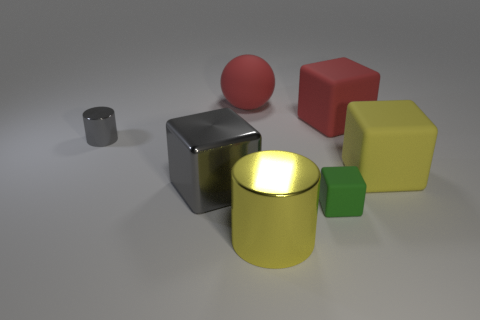Subtract all purple cubes. Subtract all yellow spheres. How many cubes are left? 4 Add 1 green rubber cubes. How many objects exist? 8 Subtract all cubes. How many objects are left? 3 Add 4 large red objects. How many large red objects exist? 6 Subtract 0 cyan cylinders. How many objects are left? 7 Subtract all tiny metal objects. Subtract all purple metallic cubes. How many objects are left? 6 Add 7 large metal cubes. How many large metal cubes are left? 8 